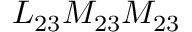<formula> <loc_0><loc_0><loc_500><loc_500>L _ { 2 3 } M _ { 2 3 } M _ { 2 3 }</formula> 